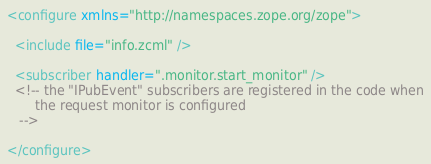Convert code to text. <code><loc_0><loc_0><loc_500><loc_500><_XML_><configure xmlns="http://namespaces.zope.org/zope">

  <include file="info.zcml" />

  <subscriber handler=".monitor.start_monitor" />
  <!-- the "IPubEvent" subscribers are registered in the code when
       the request monitor is configured
   -->

</configure>
</code> 